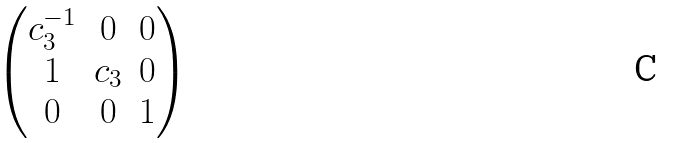Convert formula to latex. <formula><loc_0><loc_0><loc_500><loc_500>\begin{pmatrix} c _ { 3 } ^ { - 1 } & 0 & 0 \\ 1 & c _ { 3 } & 0 \\ 0 & 0 & 1 \end{pmatrix}</formula> 